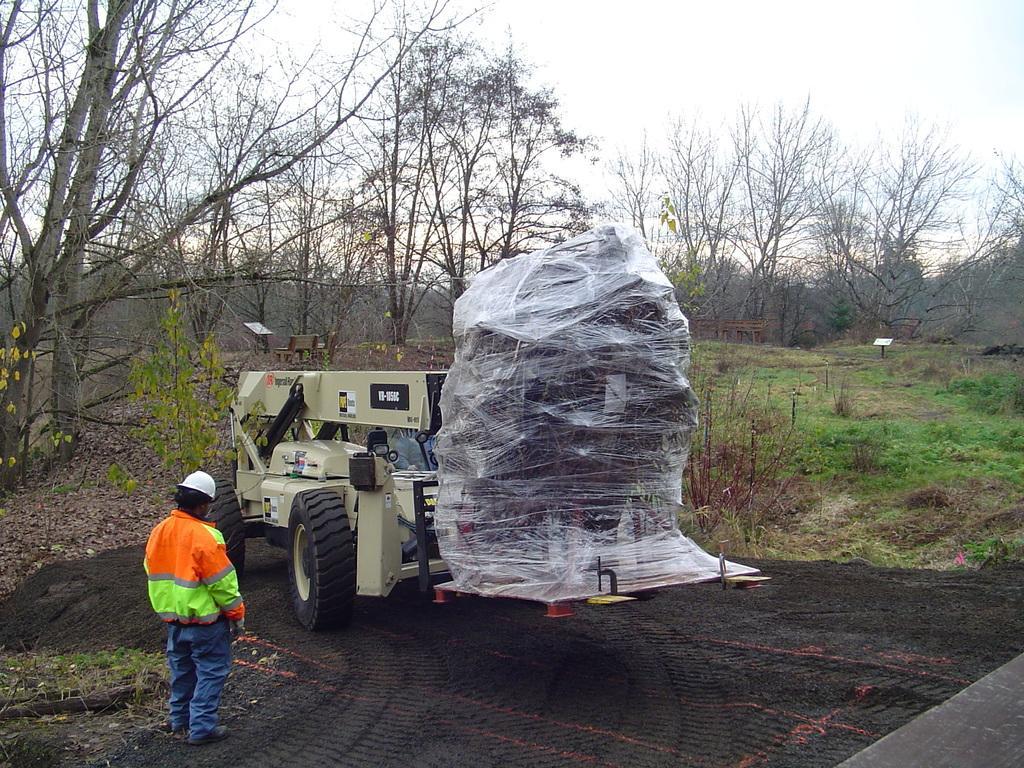How would you summarize this image in a sentence or two? In this image there is a sky, there are trees, there are plants, there is grass, there is a bench, there is a vehicle, there is a person standing. 